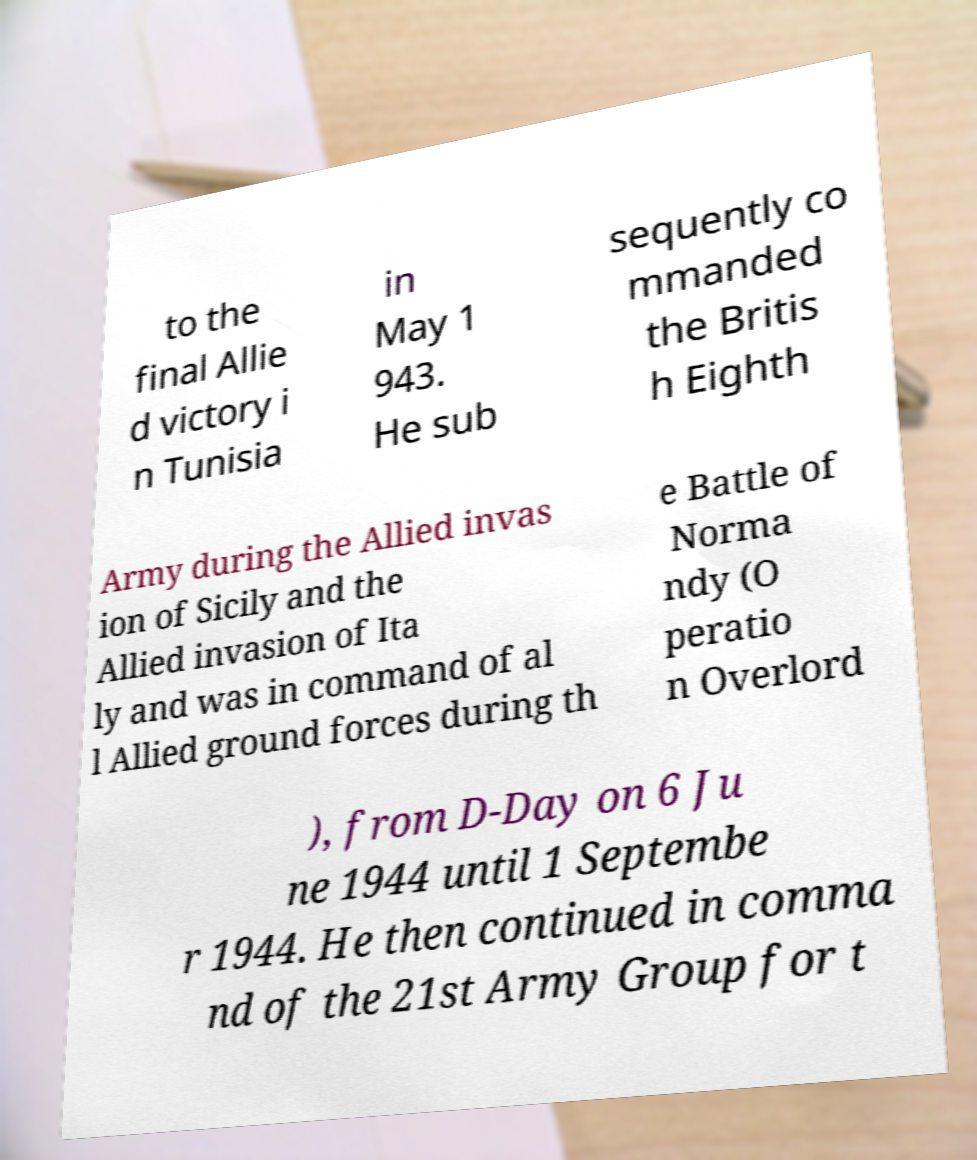There's text embedded in this image that I need extracted. Can you transcribe it verbatim? to the final Allie d victory i n Tunisia in May 1 943. He sub sequently co mmanded the Britis h Eighth Army during the Allied invas ion of Sicily and the Allied invasion of Ita ly and was in command of al l Allied ground forces during th e Battle of Norma ndy (O peratio n Overlord ), from D-Day on 6 Ju ne 1944 until 1 Septembe r 1944. He then continued in comma nd of the 21st Army Group for t 